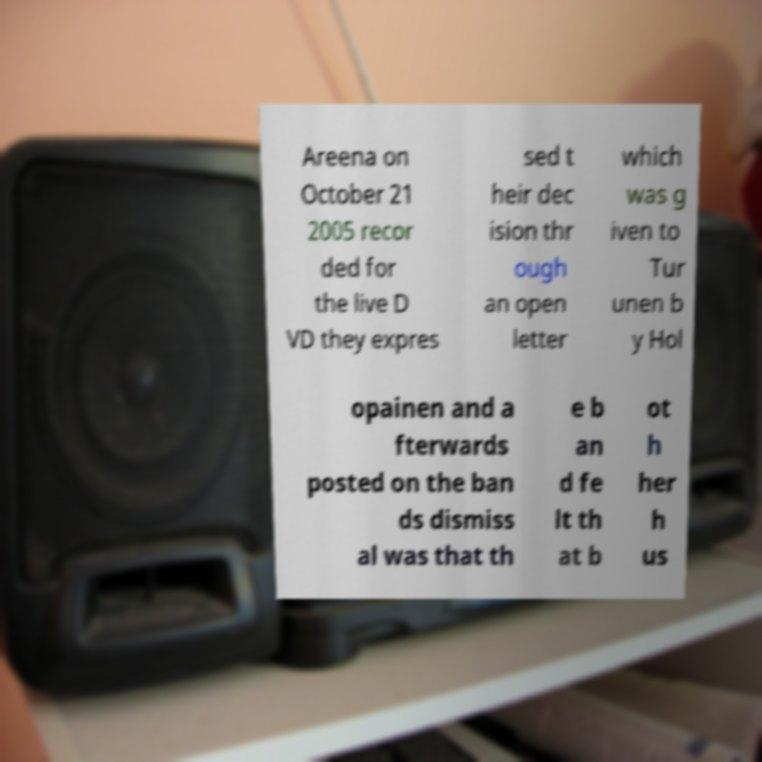Can you read and provide the text displayed in the image?This photo seems to have some interesting text. Can you extract and type it out for me? Areena on October 21 2005 recor ded for the live D VD they expres sed t heir dec ision thr ough an open letter which was g iven to Tur unen b y Hol opainen and a fterwards posted on the ban ds dismiss al was that th e b an d fe lt th at b ot h her h us 